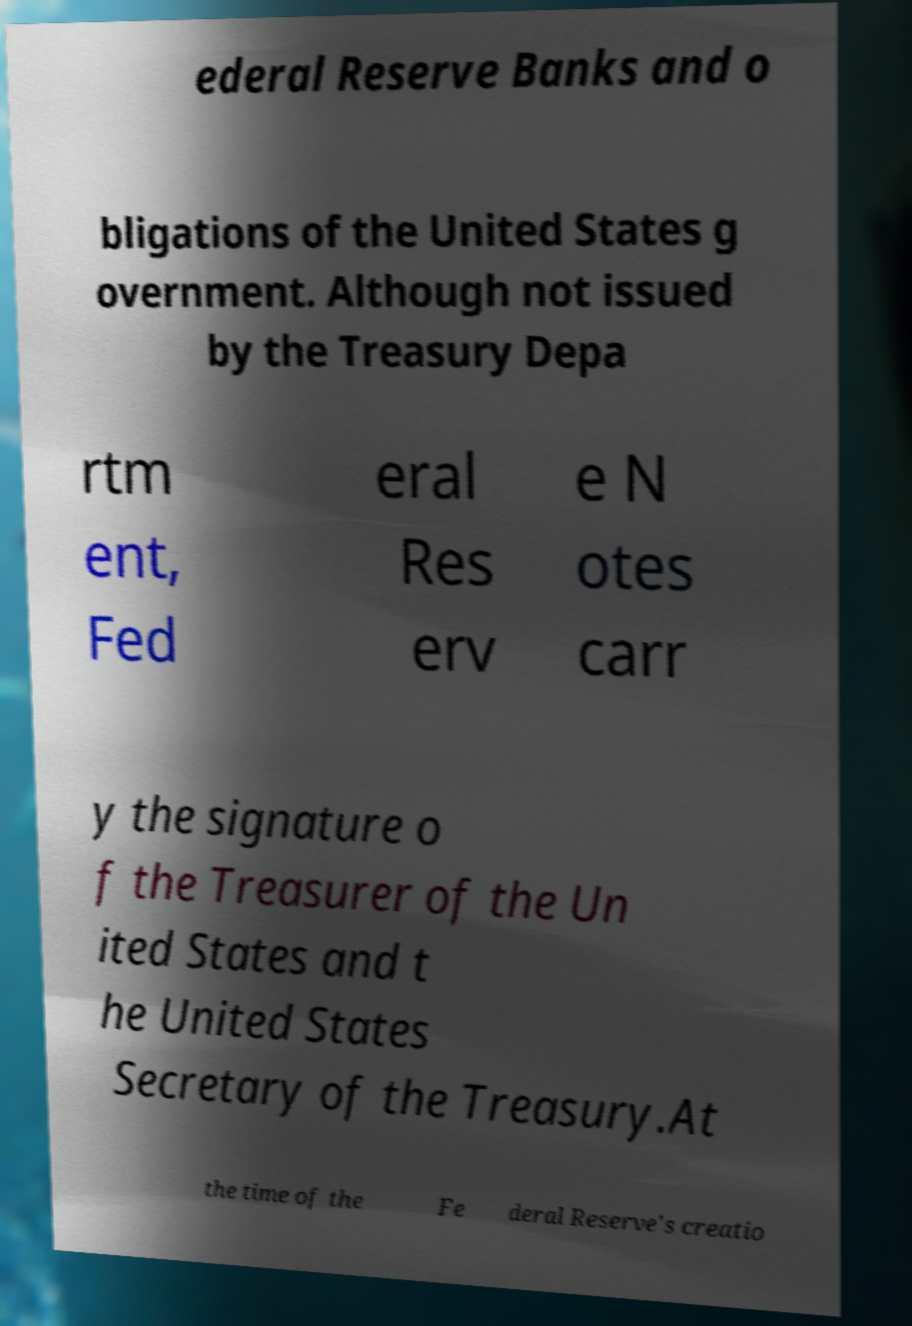There's text embedded in this image that I need extracted. Can you transcribe it verbatim? ederal Reserve Banks and o bligations of the United States g overnment. Although not issued by the Treasury Depa rtm ent, Fed eral Res erv e N otes carr y the signature o f the Treasurer of the Un ited States and t he United States Secretary of the Treasury.At the time of the Fe deral Reserve's creatio 